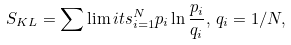Convert formula to latex. <formula><loc_0><loc_0><loc_500><loc_500>S _ { K L } = \sum \lim i t s _ { i = 1 } ^ { N } p _ { i } \ln { \frac { p _ { i } } { q _ { i } } } , \, q _ { i } = 1 / N ,</formula> 